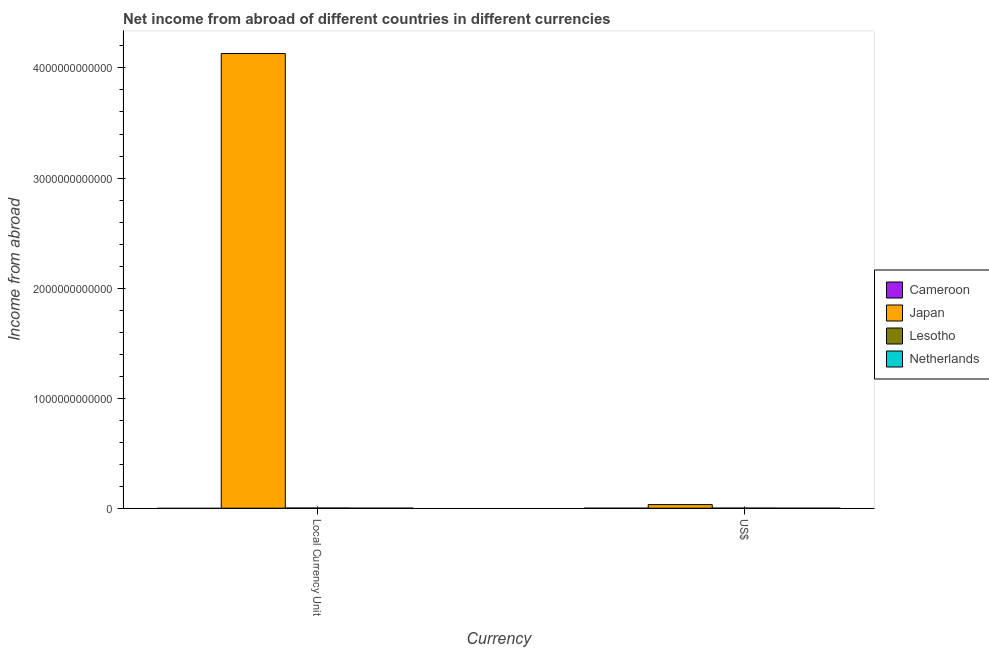How many different coloured bars are there?
Provide a short and direct response. 2. Are the number of bars on each tick of the X-axis equal?
Give a very brief answer. Yes. What is the label of the 1st group of bars from the left?
Offer a terse response. Local Currency Unit. Across all countries, what is the maximum income from abroad in constant 2005 us$?
Provide a short and direct response. 4.13e+12. Across all countries, what is the minimum income from abroad in us$?
Offer a very short reply. 0. In which country was the income from abroad in us$ maximum?
Provide a succinct answer. Japan. What is the total income from abroad in us$ in the graph?
Offer a very short reply. 3.30e+1. What is the difference between the income from abroad in us$ in Japan and that in Lesotho?
Your response must be concise. 3.22e+1. What is the difference between the income from abroad in us$ in Cameroon and the income from abroad in constant 2005 us$ in Lesotho?
Provide a succinct answer. -1.09e+09. What is the average income from abroad in constant 2005 us$ per country?
Ensure brevity in your answer.  1.03e+12. What is the difference between the income from abroad in us$ and income from abroad in constant 2005 us$ in Japan?
Ensure brevity in your answer.  -4.10e+12. What is the ratio of the income from abroad in us$ in Japan to that in Lesotho?
Provide a short and direct response. 85.67. How many bars are there?
Offer a very short reply. 4. Are all the bars in the graph horizontal?
Your response must be concise. No. What is the difference between two consecutive major ticks on the Y-axis?
Make the answer very short. 1.00e+12. Are the values on the major ticks of Y-axis written in scientific E-notation?
Your answer should be compact. No. Does the graph contain any zero values?
Keep it short and to the point. Yes. Does the graph contain grids?
Your answer should be very brief. No. How are the legend labels stacked?
Provide a succinct answer. Vertical. What is the title of the graph?
Make the answer very short. Net income from abroad of different countries in different currencies. Does "Angola" appear as one of the legend labels in the graph?
Your answer should be compact. No. What is the label or title of the X-axis?
Ensure brevity in your answer.  Currency. What is the label or title of the Y-axis?
Give a very brief answer. Income from abroad. What is the Income from abroad of Cameroon in Local Currency Unit?
Your answer should be very brief. 0. What is the Income from abroad of Japan in Local Currency Unit?
Offer a very short reply. 4.13e+12. What is the Income from abroad in Lesotho in Local Currency Unit?
Provide a short and direct response. 1.09e+09. What is the Income from abroad in Netherlands in Local Currency Unit?
Your response must be concise. 0. What is the Income from abroad of Japan in US$?
Provide a succinct answer. 3.26e+1. What is the Income from abroad in Lesotho in US$?
Offer a terse response. 3.81e+08. What is the Income from abroad of Netherlands in US$?
Your response must be concise. 0. Across all Currency, what is the maximum Income from abroad in Japan?
Give a very brief answer. 4.13e+12. Across all Currency, what is the maximum Income from abroad in Lesotho?
Provide a short and direct response. 1.09e+09. Across all Currency, what is the minimum Income from abroad of Japan?
Your answer should be very brief. 3.26e+1. Across all Currency, what is the minimum Income from abroad of Lesotho?
Make the answer very short. 3.81e+08. What is the total Income from abroad of Cameroon in the graph?
Keep it short and to the point. 0. What is the total Income from abroad of Japan in the graph?
Provide a short and direct response. 4.16e+12. What is the total Income from abroad of Lesotho in the graph?
Your answer should be compact. 1.47e+09. What is the total Income from abroad of Netherlands in the graph?
Your answer should be compact. 0. What is the difference between the Income from abroad in Japan in Local Currency Unit and that in US$?
Give a very brief answer. 4.10e+12. What is the difference between the Income from abroad in Lesotho in Local Currency Unit and that in US$?
Your response must be concise. 7.05e+08. What is the difference between the Income from abroad in Japan in Local Currency Unit and the Income from abroad in Lesotho in US$?
Provide a succinct answer. 4.13e+12. What is the average Income from abroad of Cameroon per Currency?
Offer a very short reply. 0. What is the average Income from abroad of Japan per Currency?
Keep it short and to the point. 2.08e+12. What is the average Income from abroad in Lesotho per Currency?
Provide a succinct answer. 7.33e+08. What is the difference between the Income from abroad in Japan and Income from abroad in Lesotho in Local Currency Unit?
Provide a short and direct response. 4.13e+12. What is the difference between the Income from abroad in Japan and Income from abroad in Lesotho in US$?
Your response must be concise. 3.22e+1. What is the ratio of the Income from abroad of Japan in Local Currency Unit to that in US$?
Keep it short and to the point. 126.65. What is the ratio of the Income from abroad in Lesotho in Local Currency Unit to that in US$?
Your answer should be compact. 2.85. What is the difference between the highest and the second highest Income from abroad in Japan?
Keep it short and to the point. 4.10e+12. What is the difference between the highest and the second highest Income from abroad of Lesotho?
Your answer should be very brief. 7.05e+08. What is the difference between the highest and the lowest Income from abroad in Japan?
Keep it short and to the point. 4.10e+12. What is the difference between the highest and the lowest Income from abroad of Lesotho?
Ensure brevity in your answer.  7.05e+08. 